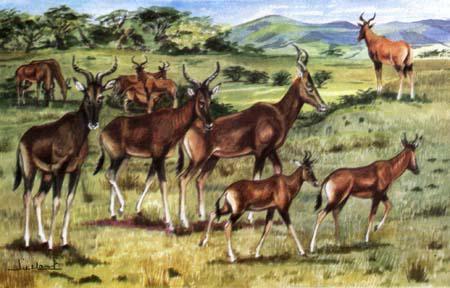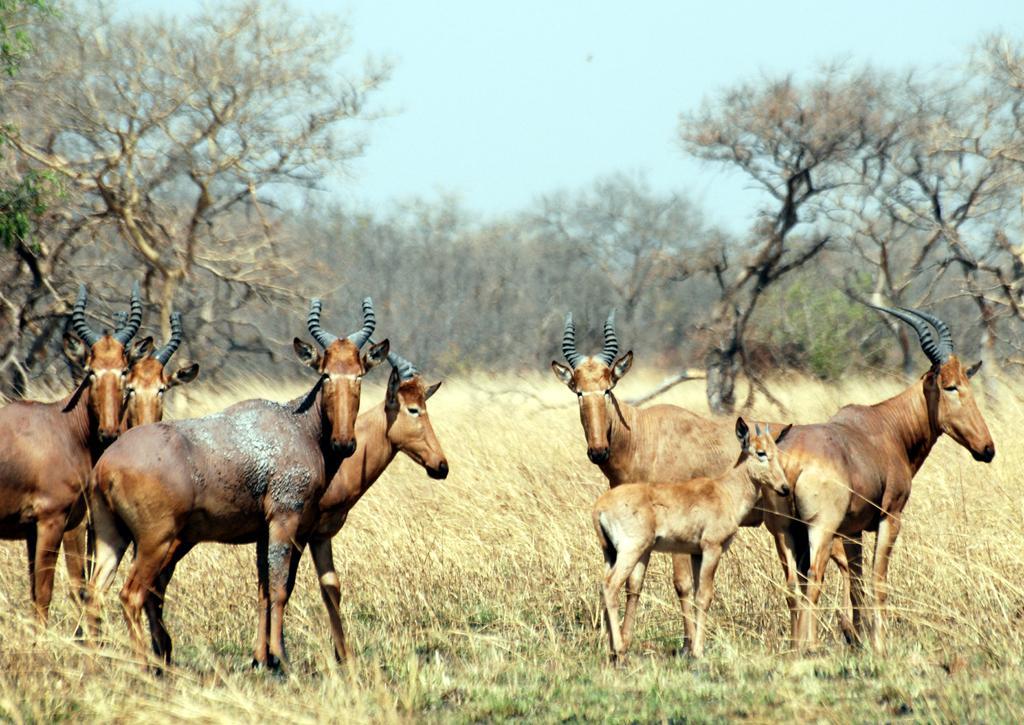The first image is the image on the left, the second image is the image on the right. Evaluate the accuracy of this statement regarding the images: "There are no more than three animals in the image on the right.". Is it true? Answer yes or no. No. The first image is the image on the left, the second image is the image on the right. Examine the images to the left and right. Is the description "The right image contains no more than three antelope." accurate? Answer yes or no. No. 